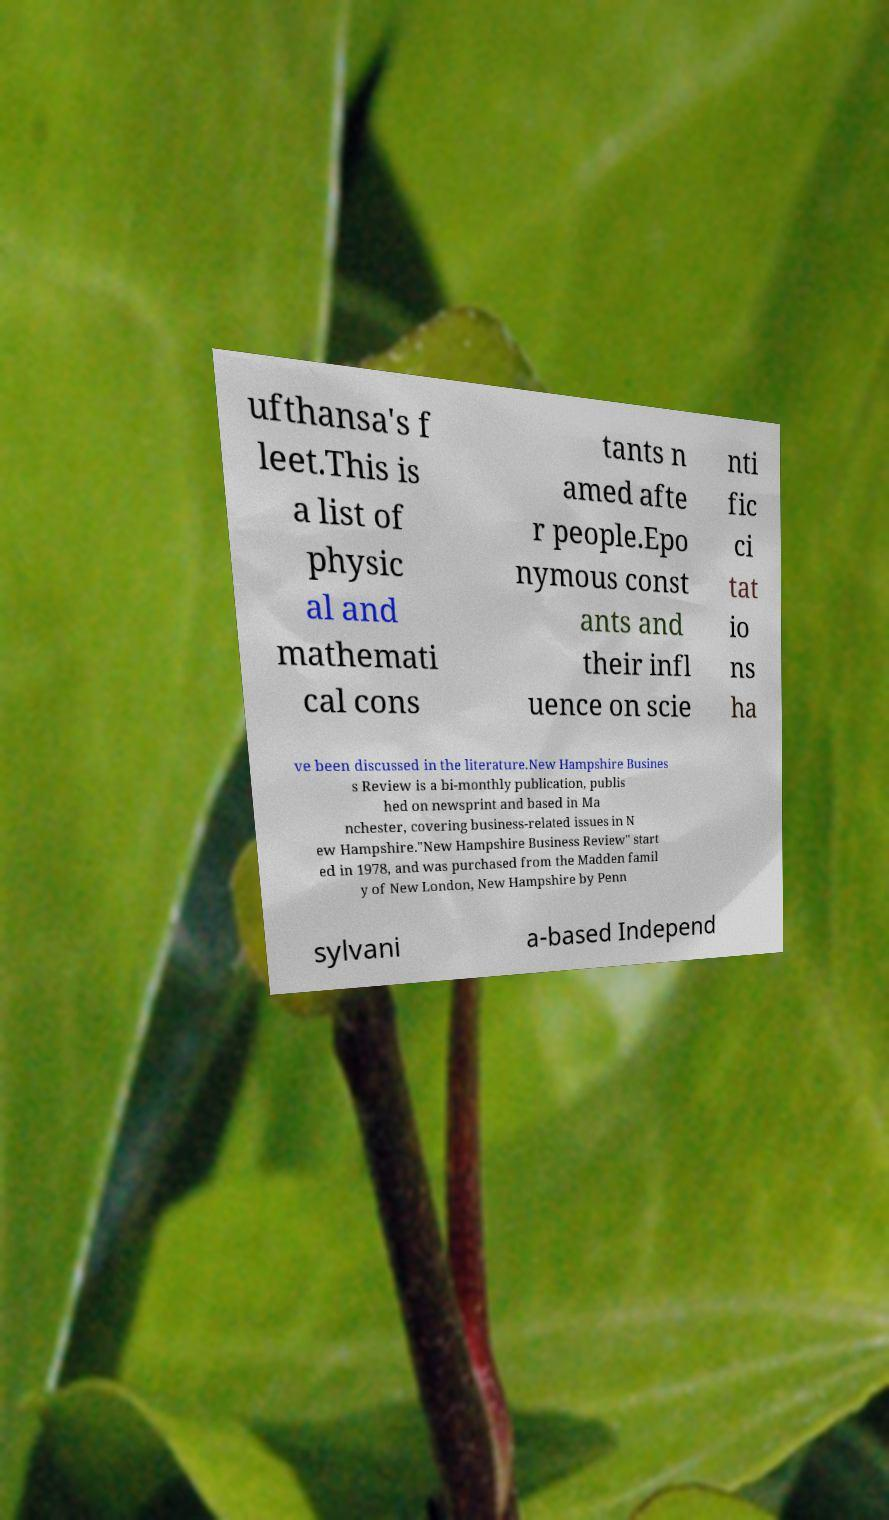Could you assist in decoding the text presented in this image and type it out clearly? ufthansa's f leet.This is a list of physic al and mathemati cal cons tants n amed afte r people.Epo nymous const ants and their infl uence on scie nti fic ci tat io ns ha ve been discussed in the literature.New Hampshire Busines s Review is a bi-monthly publication, publis hed on newsprint and based in Ma nchester, covering business-related issues in N ew Hampshire."New Hampshire Business Review" start ed in 1978, and was purchased from the Madden famil y of New London, New Hampshire by Penn sylvani a-based Independ 